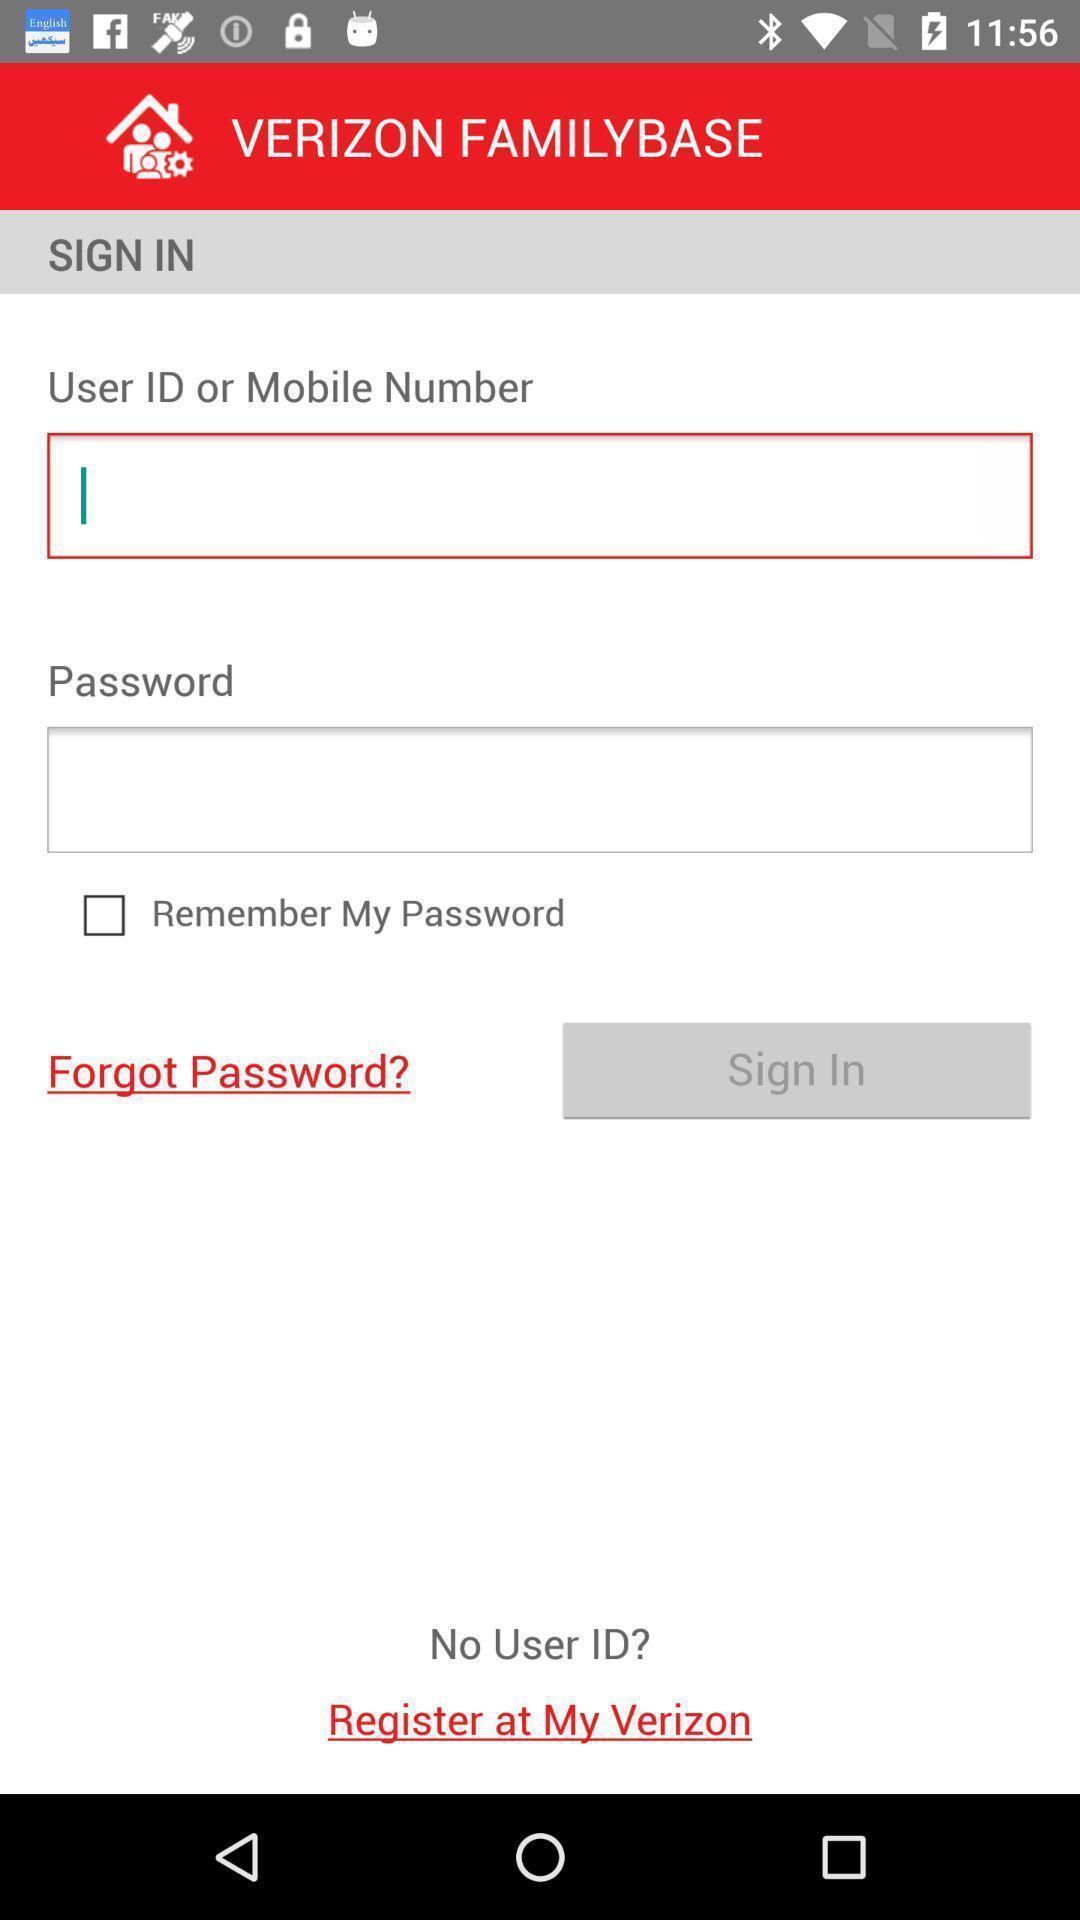Describe the visual elements of this screenshot. Sign in page of a social app. 